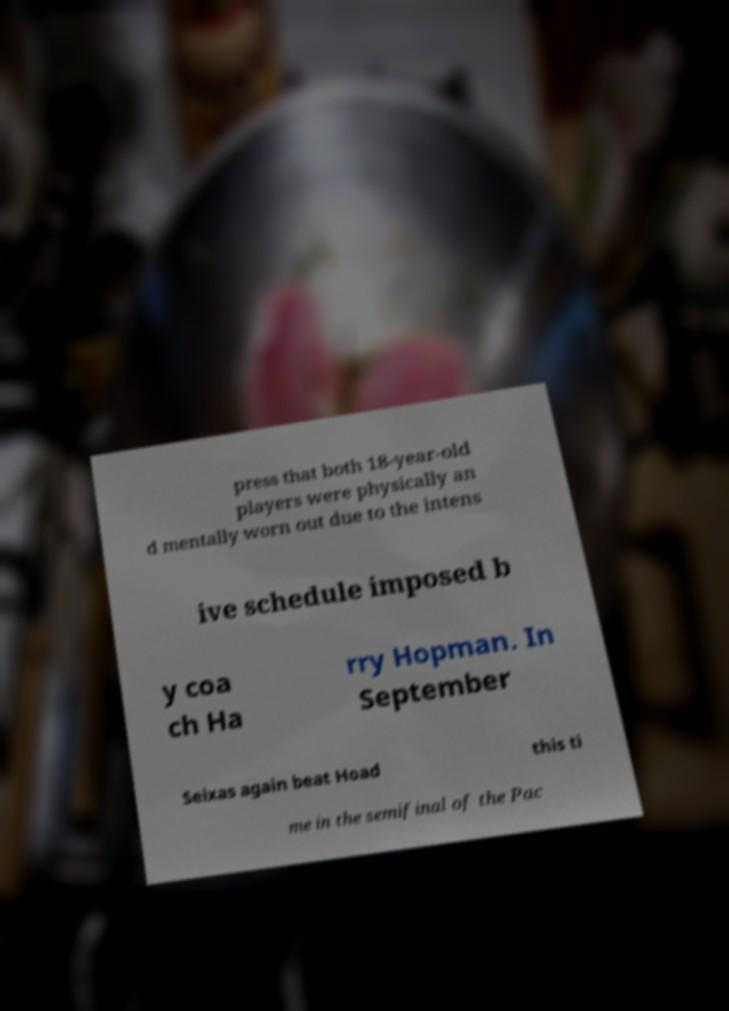Can you read and provide the text displayed in the image?This photo seems to have some interesting text. Can you extract and type it out for me? press that both 18-year-old players were physically an d mentally worn out due to the intens ive schedule imposed b y coa ch Ha rry Hopman. In September Seixas again beat Hoad this ti me in the semifinal of the Pac 